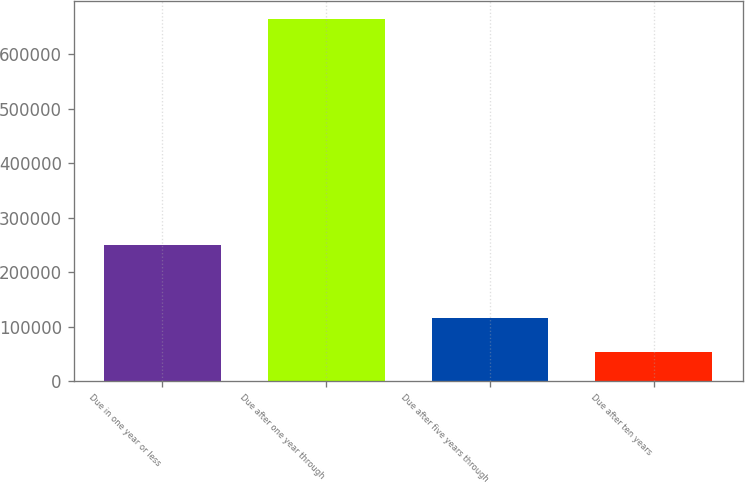Convert chart. <chart><loc_0><loc_0><loc_500><loc_500><bar_chart><fcel>Due in one year or less<fcel>Due after one year through<fcel>Due after five years through<fcel>Due after ten years<nl><fcel>250163<fcel>664564<fcel>115650<fcel>54659<nl></chart> 